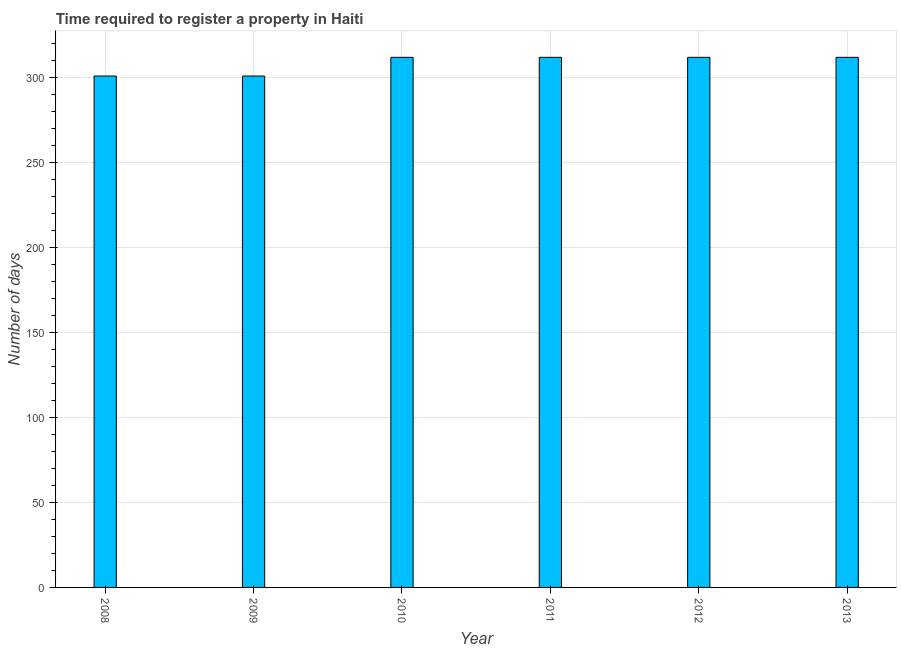What is the title of the graph?
Make the answer very short. Time required to register a property in Haiti. What is the label or title of the Y-axis?
Provide a succinct answer. Number of days. What is the number of days required to register property in 2013?
Offer a very short reply. 312. Across all years, what is the maximum number of days required to register property?
Keep it short and to the point. 312. Across all years, what is the minimum number of days required to register property?
Offer a terse response. 301. In which year was the number of days required to register property minimum?
Ensure brevity in your answer.  2008. What is the sum of the number of days required to register property?
Keep it short and to the point. 1850. What is the average number of days required to register property per year?
Keep it short and to the point. 308. What is the median number of days required to register property?
Give a very brief answer. 312. In how many years, is the number of days required to register property greater than 30 days?
Offer a terse response. 6. Do a majority of the years between 2009 and 2013 (inclusive) have number of days required to register property greater than 300 days?
Make the answer very short. Yes. What is the difference between the highest and the second highest number of days required to register property?
Provide a short and direct response. 0. In how many years, is the number of days required to register property greater than the average number of days required to register property taken over all years?
Make the answer very short. 4. How many bars are there?
Ensure brevity in your answer.  6. Are all the bars in the graph horizontal?
Ensure brevity in your answer.  No. How many years are there in the graph?
Provide a succinct answer. 6. What is the difference between two consecutive major ticks on the Y-axis?
Provide a short and direct response. 50. What is the Number of days of 2008?
Provide a succinct answer. 301. What is the Number of days of 2009?
Your answer should be very brief. 301. What is the Number of days of 2010?
Provide a succinct answer. 312. What is the Number of days of 2011?
Keep it short and to the point. 312. What is the Number of days of 2012?
Offer a terse response. 312. What is the Number of days in 2013?
Ensure brevity in your answer.  312. What is the difference between the Number of days in 2008 and 2009?
Your response must be concise. 0. What is the difference between the Number of days in 2009 and 2012?
Your response must be concise. -11. What is the difference between the Number of days in 2009 and 2013?
Keep it short and to the point. -11. What is the difference between the Number of days in 2010 and 2011?
Give a very brief answer. 0. What is the difference between the Number of days in 2010 and 2013?
Provide a succinct answer. 0. What is the difference between the Number of days in 2012 and 2013?
Provide a succinct answer. 0. What is the ratio of the Number of days in 2008 to that in 2009?
Make the answer very short. 1. What is the ratio of the Number of days in 2008 to that in 2012?
Ensure brevity in your answer.  0.96. What is the ratio of the Number of days in 2009 to that in 2010?
Offer a terse response. 0.96. What is the ratio of the Number of days in 2009 to that in 2011?
Your response must be concise. 0.96. What is the ratio of the Number of days in 2009 to that in 2013?
Your answer should be compact. 0.96. What is the ratio of the Number of days in 2010 to that in 2011?
Your answer should be very brief. 1. What is the ratio of the Number of days in 2011 to that in 2012?
Make the answer very short. 1. What is the ratio of the Number of days in 2011 to that in 2013?
Provide a short and direct response. 1. What is the ratio of the Number of days in 2012 to that in 2013?
Ensure brevity in your answer.  1. 